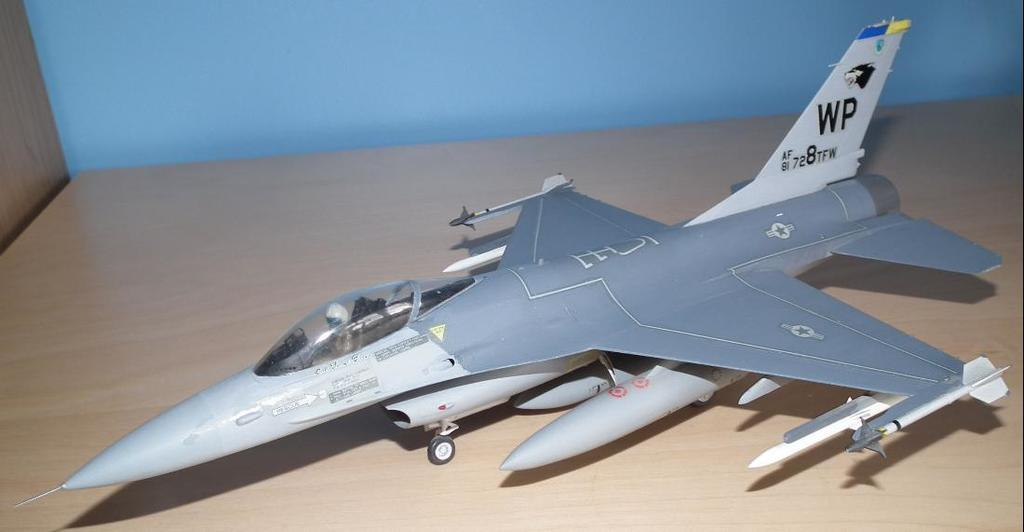<image>
Present a compact description of the photo's key features. A scale model of a fighter jet with tail letters WP. 